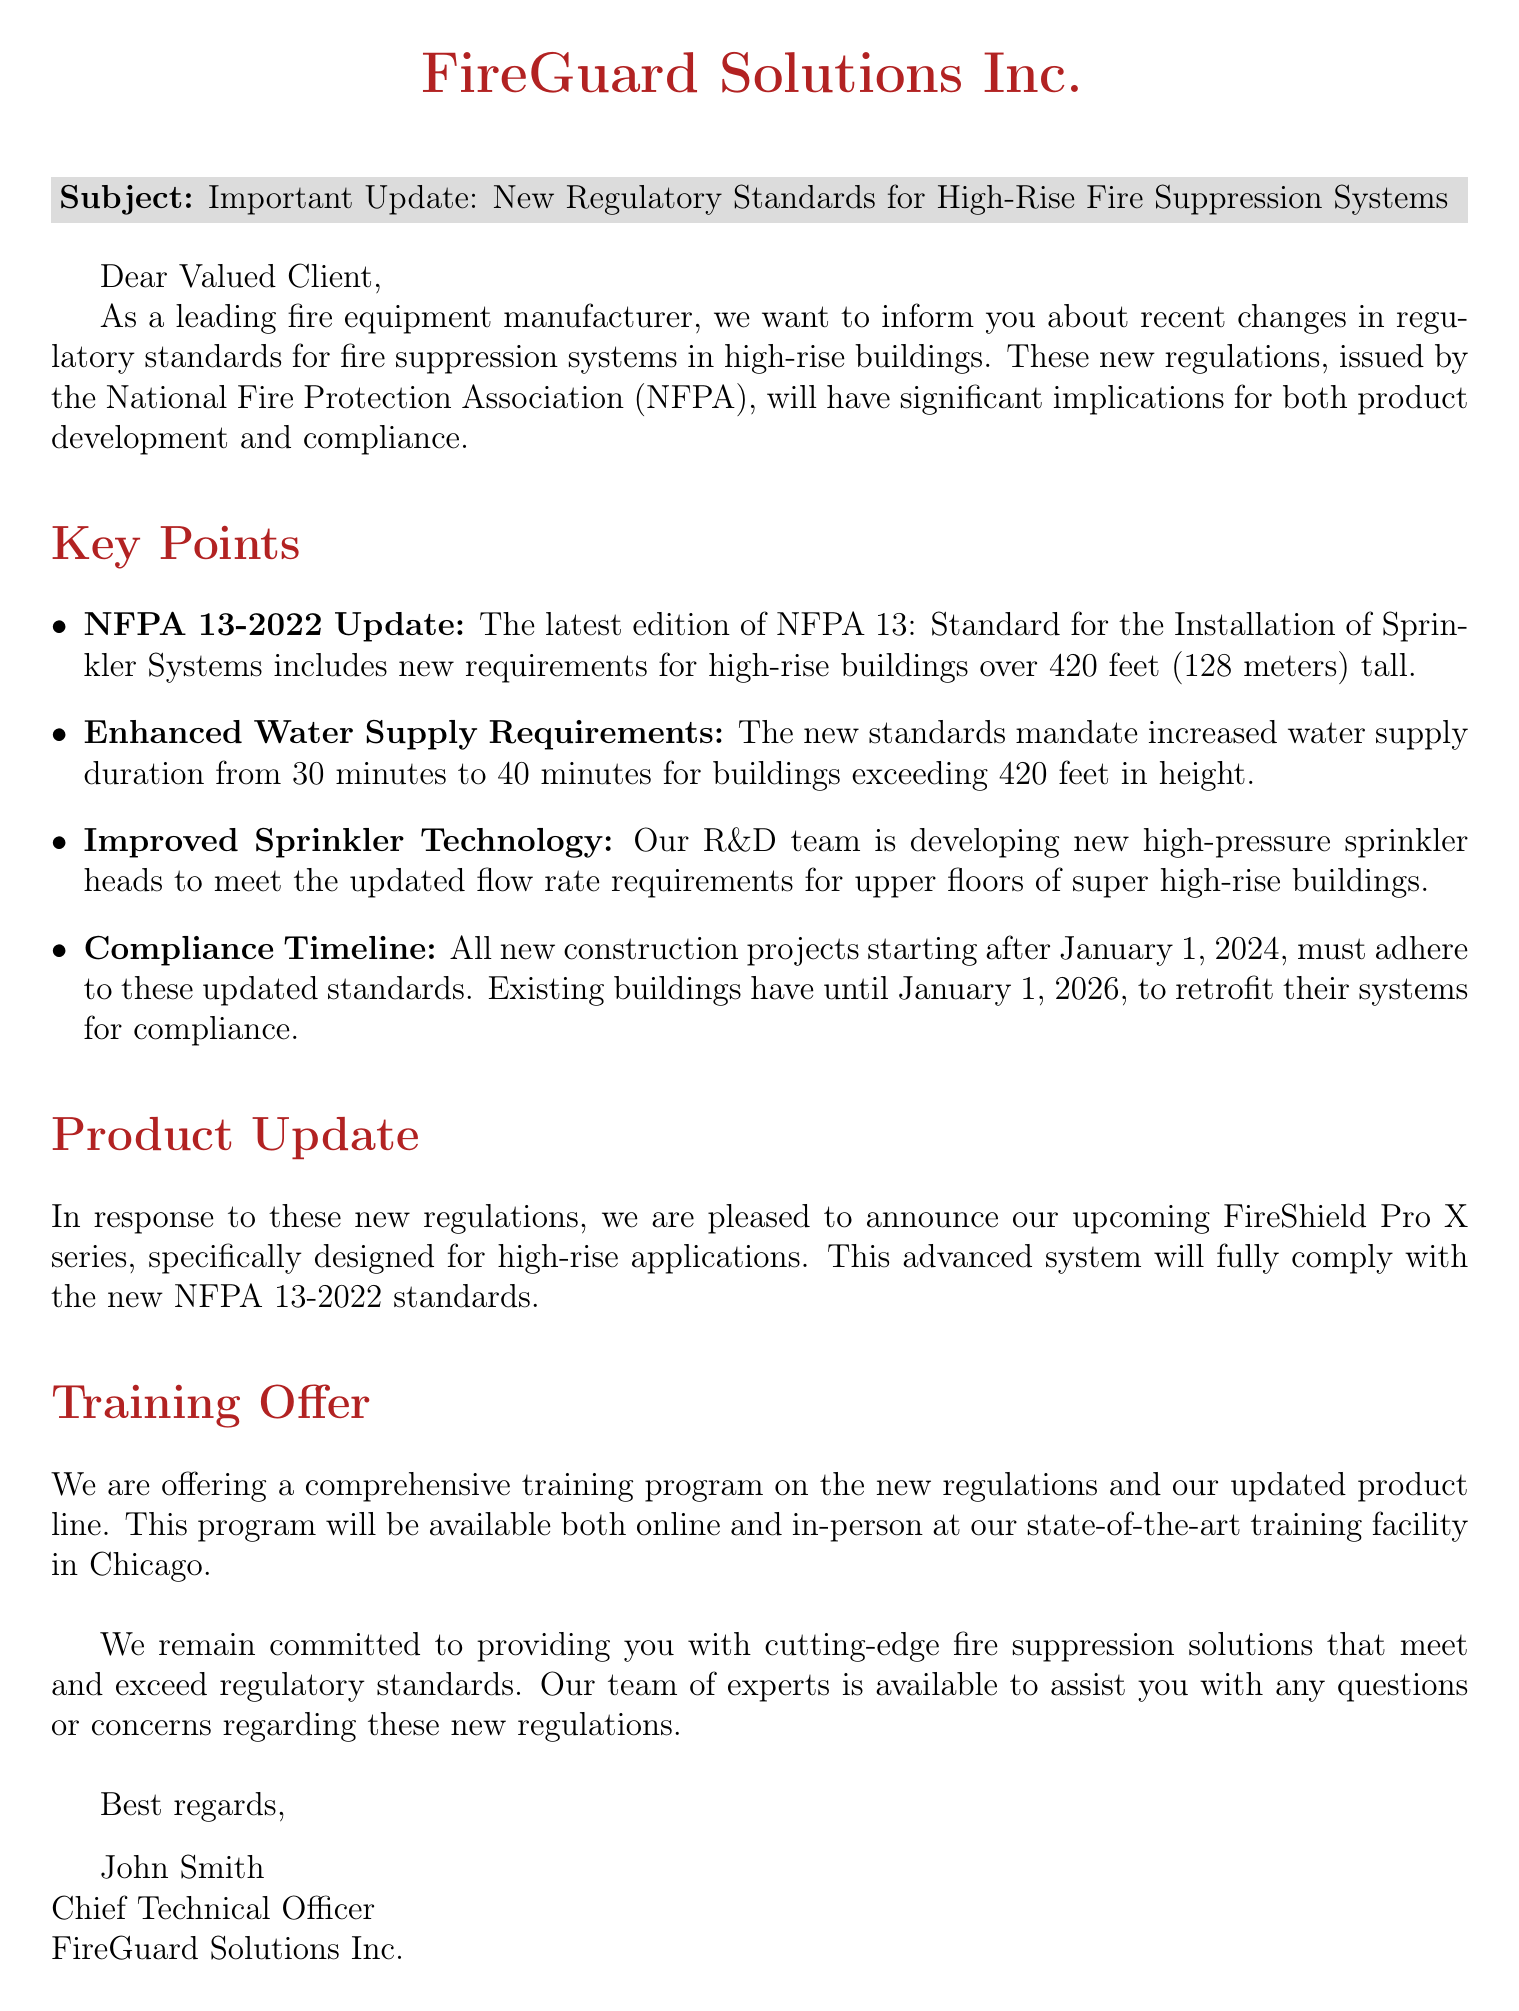What is the subject of the email? The subject of the email is stated clearly at the beginning, indicating the focus on regulatory standards for fire suppression systems in high-rise buildings.
Answer: Important Update: New Regulatory Standards for High-Rise Fire Suppression Systems Who issued the new regulatory standards? The document mentions the organization responsible for the new regulations, specifically indicating its authority in fire safety.
Answer: National Fire Protection Association What is the new water supply duration requirement? The document specifies the updated requirement for water supply duration in high-rise buildings, which has been increased.
Answer: 40 minutes When must new construction projects comply with the updated standards? The document provides a specific date by which all new construction projects should adhere to the new standards.
Answer: January 1, 2024 What is the name of the new product series announced? The document introduces a new product that is being developed in response to the regulatory changes, specifying its name.
Answer: FireShield Pro X series What training program is being offered? The document describes a specific training initiative that will help clients understand the new regulations and product line.
Answer: Comprehensive training program How long do existing buildings have to retrofit their systems for compliance? The document outlines a deadline for existing buildings to comply with the updated regulations regarding fire suppression systems.
Answer: January 1, 2026 Who is the Chief Technical Officer of FireGuard Solutions Inc.? The email concludes with a signature that identifies the individual in charge of technical operations at the company.
Answer: John Smith 